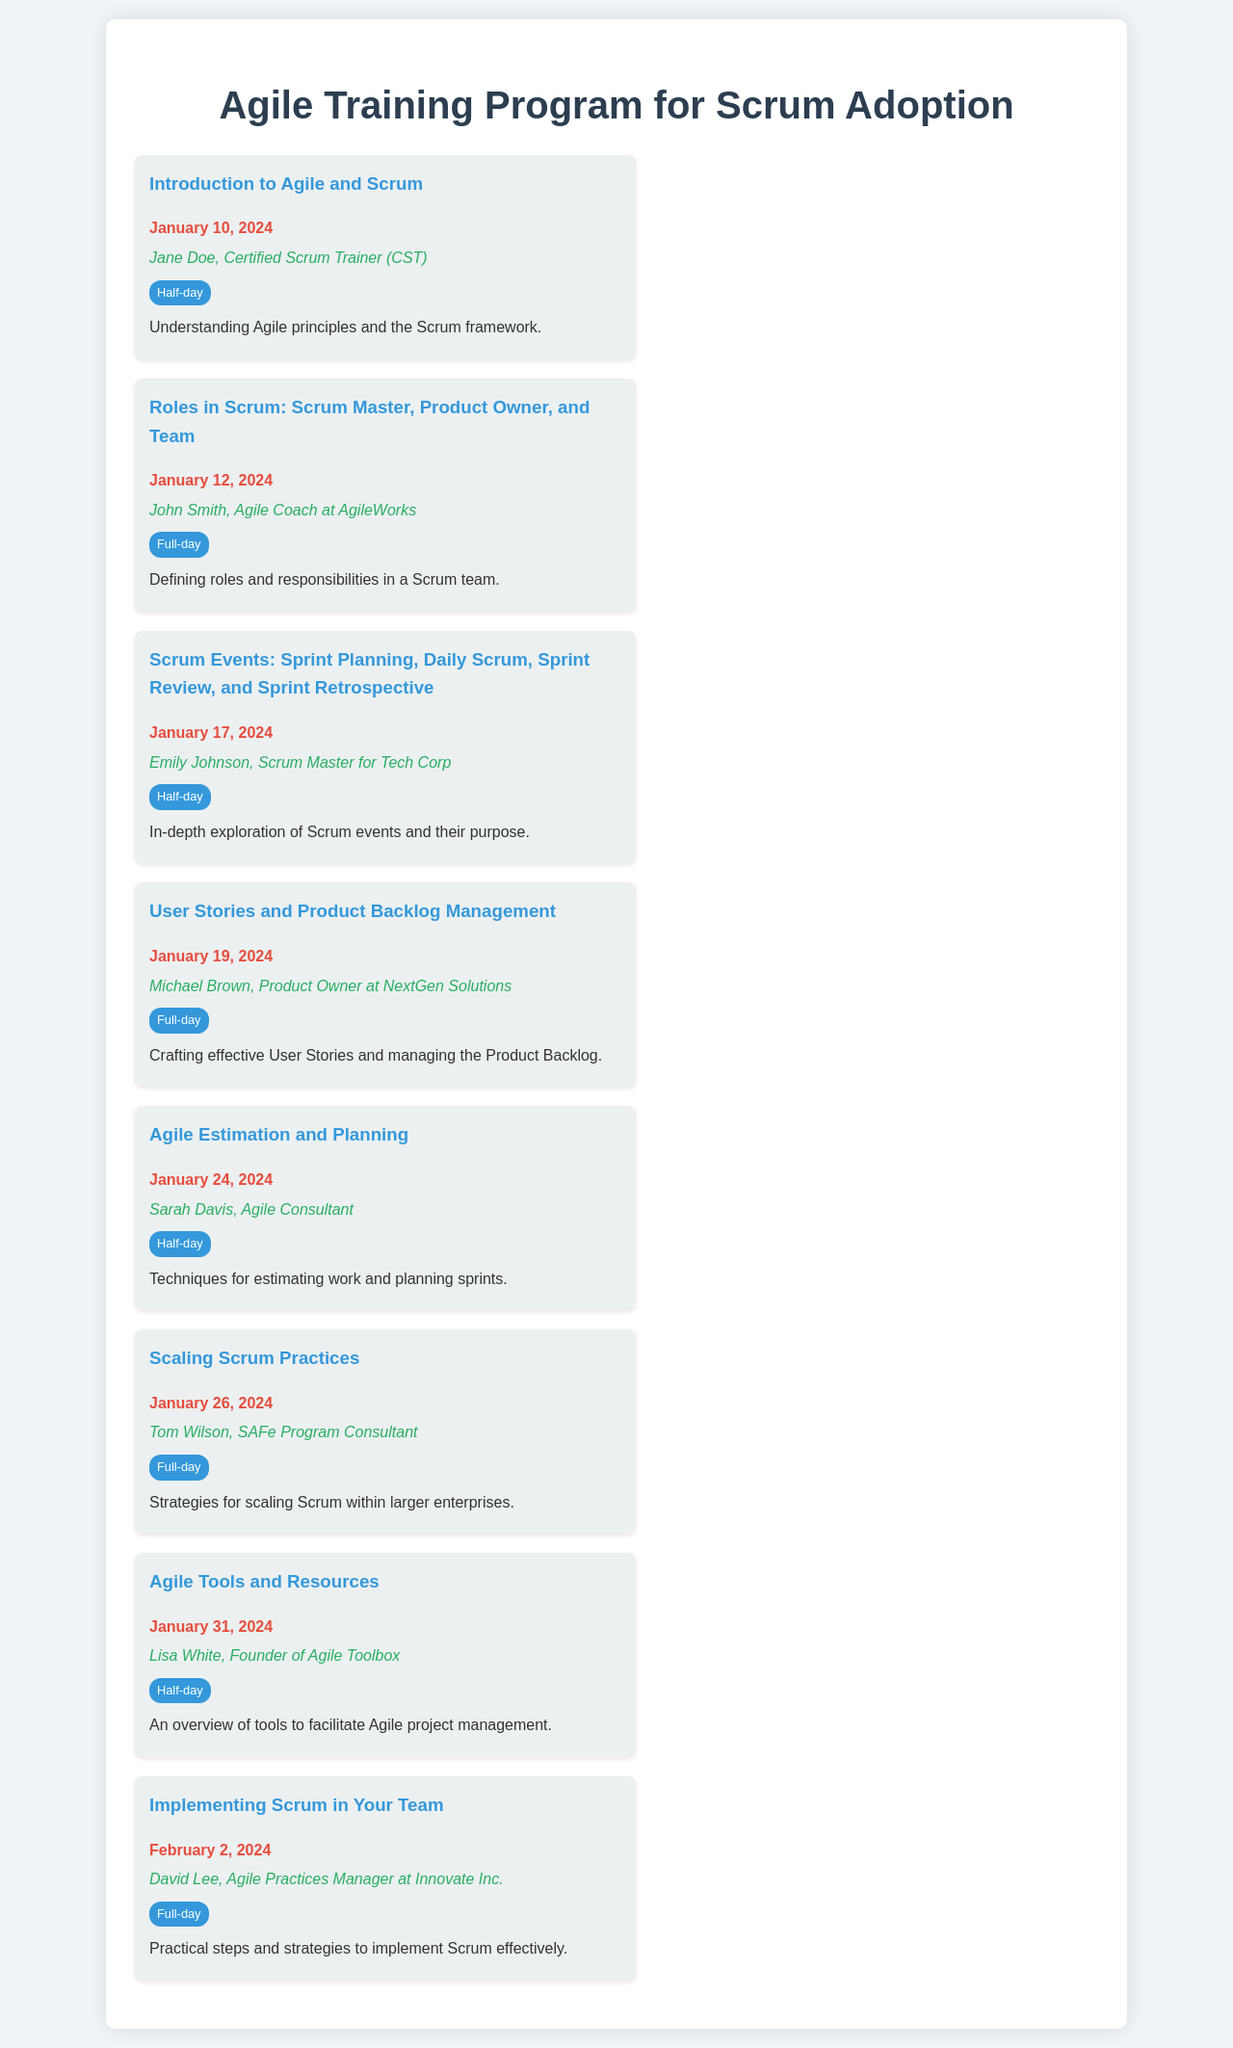what is the date of the first workshop? The first workshop, "Introduction to Agile and Scrum," is scheduled for January 10, 2024.
Answer: January 10, 2024 who is the trainer for the User Stories workshop? The workshop "User Stories and Product Backlog Management" is conducted by Michael Brown.
Answer: Michael Brown how long is the Scaling Scrum Practices workshop? The duration of the "Scaling Scrum Practices" workshop is stated as a full-day.
Answer: Full-day what is the topic of the workshop on January 31, 2024? The workshop scheduled for January 31, 2024, is "Agile Tools and Resources."
Answer: Agile Tools and Resources which trainer is associated with the workshop about implementing Scrum? The workshop "Implementing Scrum in Your Team" is led by David Lee.
Answer: David Lee how many workshops are held in January 2024? The month of January 2024 features a total of seven workshops.
Answer: Seven what is the common theme of the workshops listed? The workshops focus on teaching aspects of Agile and Scrum methodologies.
Answer: Agile and Scrum which workshop is focused on Agile estimation techniques? The workshop titled "Agile Estimation and Planning" focuses on estimation techniques.
Answer: Agile Estimation and Planning 